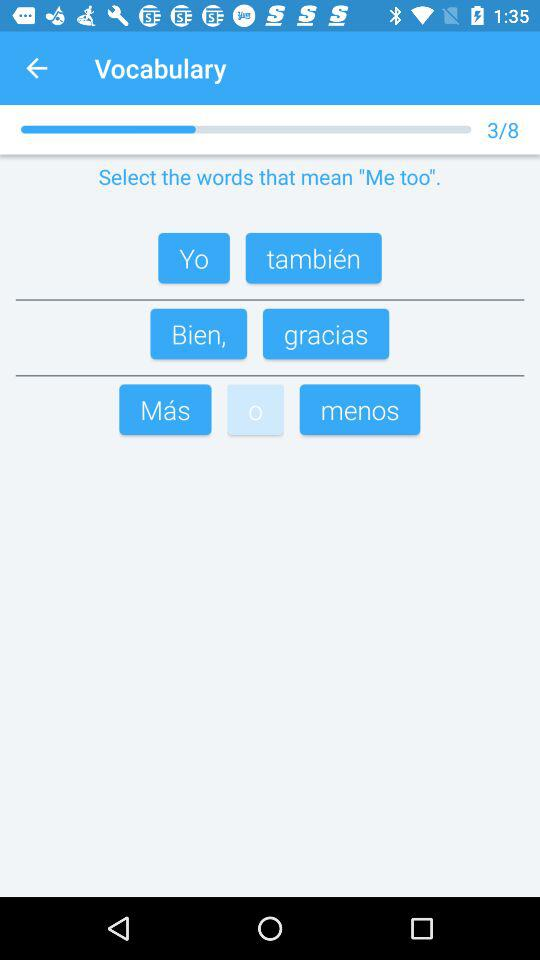How many vocabulary quizzes in total are there? There are 8 vocabulary quizzes in total. 